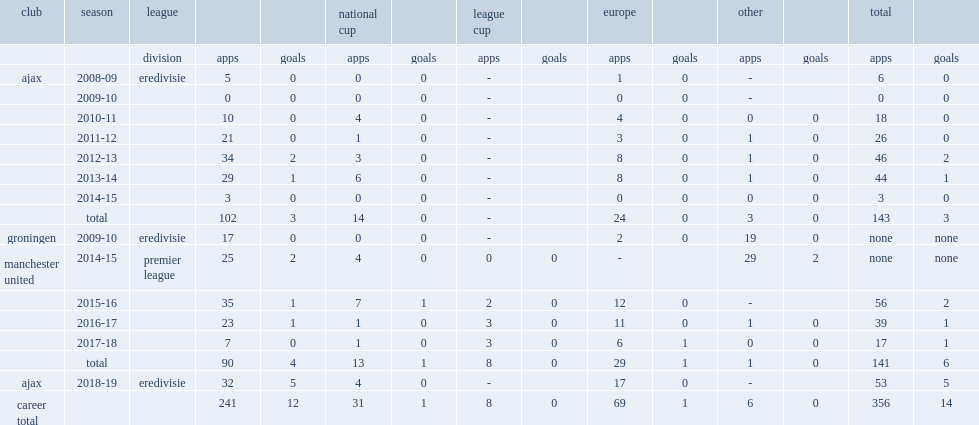In the 2010-11 season, and the 2011-12 season, which club in eredivisie did blind play for? Ajax. 